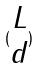<formula> <loc_0><loc_0><loc_500><loc_500>( \begin{matrix} L \\ d \end{matrix} )</formula> 